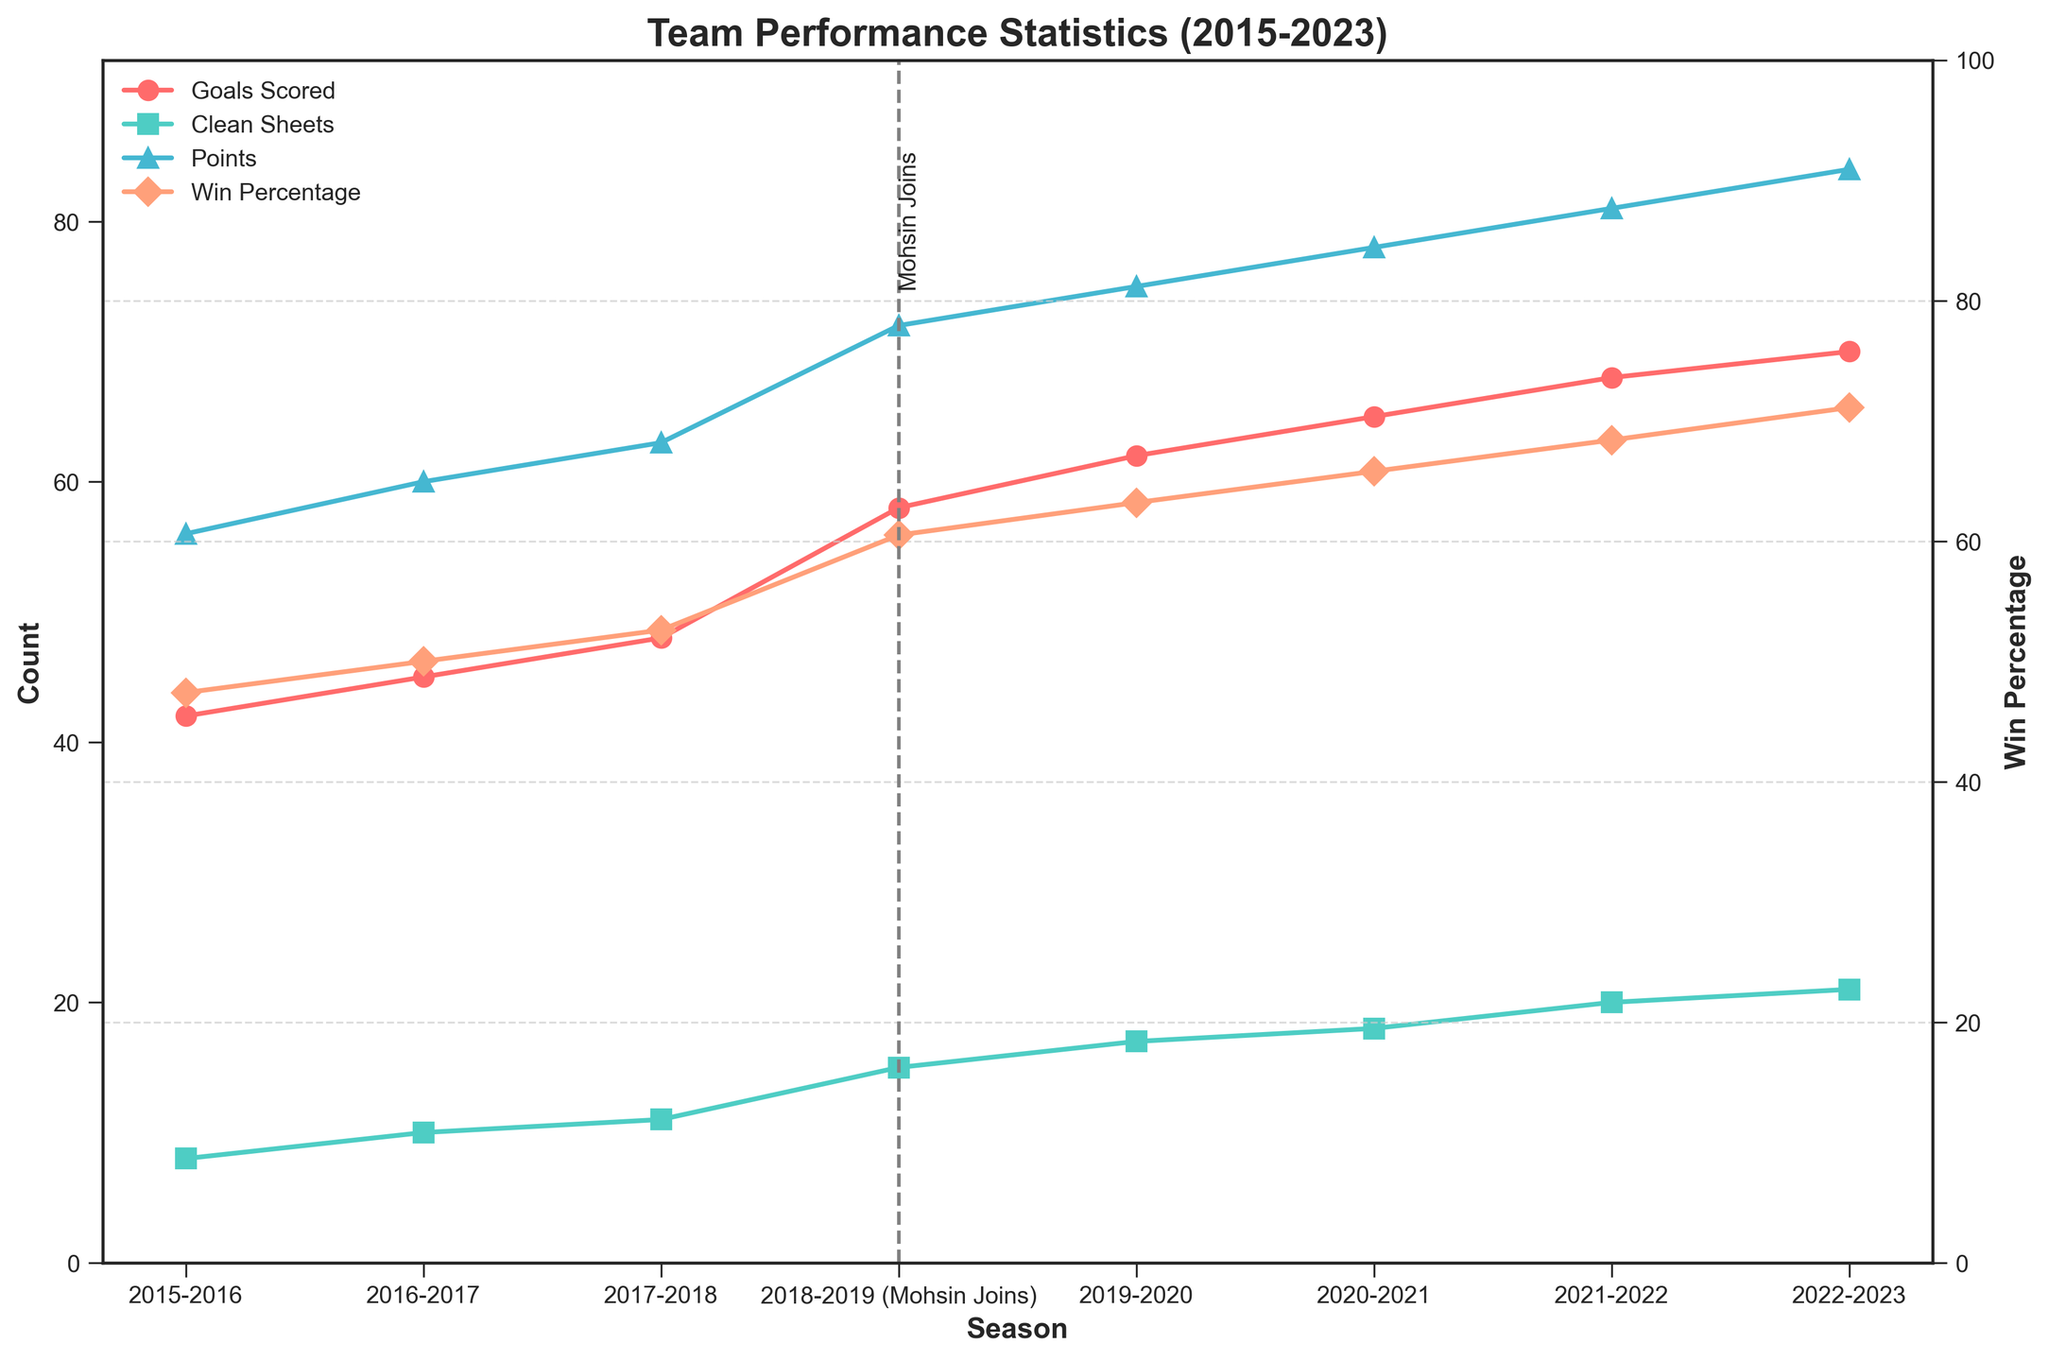What was the win percentage in the first season after Mohamed Mohsin joined the team? The figure shows that Mohamed Mohsin joined in the 2018-2019 season. The win percentage for that season is shown as 60.5%.
Answer: 60.5% How many clean sheets did the team achieve in the 2017-2018 season, and how does this compare to the clean sheets in the 2019-2020 season? The figure shows that in 2017-2018, the team had 11 clean sheets, and in the 2019-2020 season, they had 17 clean sheets. The difference is 17 - 11 = 6 more clean sheets in 2019-2020.
Answer: 6 more clean sheets What's the average number of goals scored per season before Mohamed Mohsin joined the team? Before Mohamed Mohsin joined in the 2018-2019 season, the number of goals scored per season were 42, 45, and 48. The average is (42 + 45 + 48) / 3 = 45.
Answer: 45 In which season did the team score the highest number of goals, and how many goals were scored? The highest number of goals scored is shown in the 2022-2023 season with 70 goals.
Answer: 2022-2023, 70 goals How did the win percentage change from the 2018-2019 season to the 2020-2021 season? In the 2018-2019 season, the win percentage was 60.5%. In the 2020-2021 season, the win percentage was 65.8%. The change is 65.8% - 60.5% = 5.3% increase.
Answer: 5.3% increase What is the sum of the points accumulated by the team in the seasons 2019-2020 and 2021-2022? The points for the 2019-2020 season are 75 and for the 2021-2022 season are 81. The sum is 75 + 81 = 156.
Answer: 156 How many more clean sheets did the team achieve after Mohamed Mohsin joined in 2018-2019 compared to before? Before Mohamed Mohsin joined, the number of clean sheets were 8, 10, and 11, totaling 29. After he joined, the clean sheets for the seasons were 15, 17, 18, 20, and 21, totaling 91. The difference is 91 - 29 = 62 more clean sheets.
Answer: 62 more clean sheets 